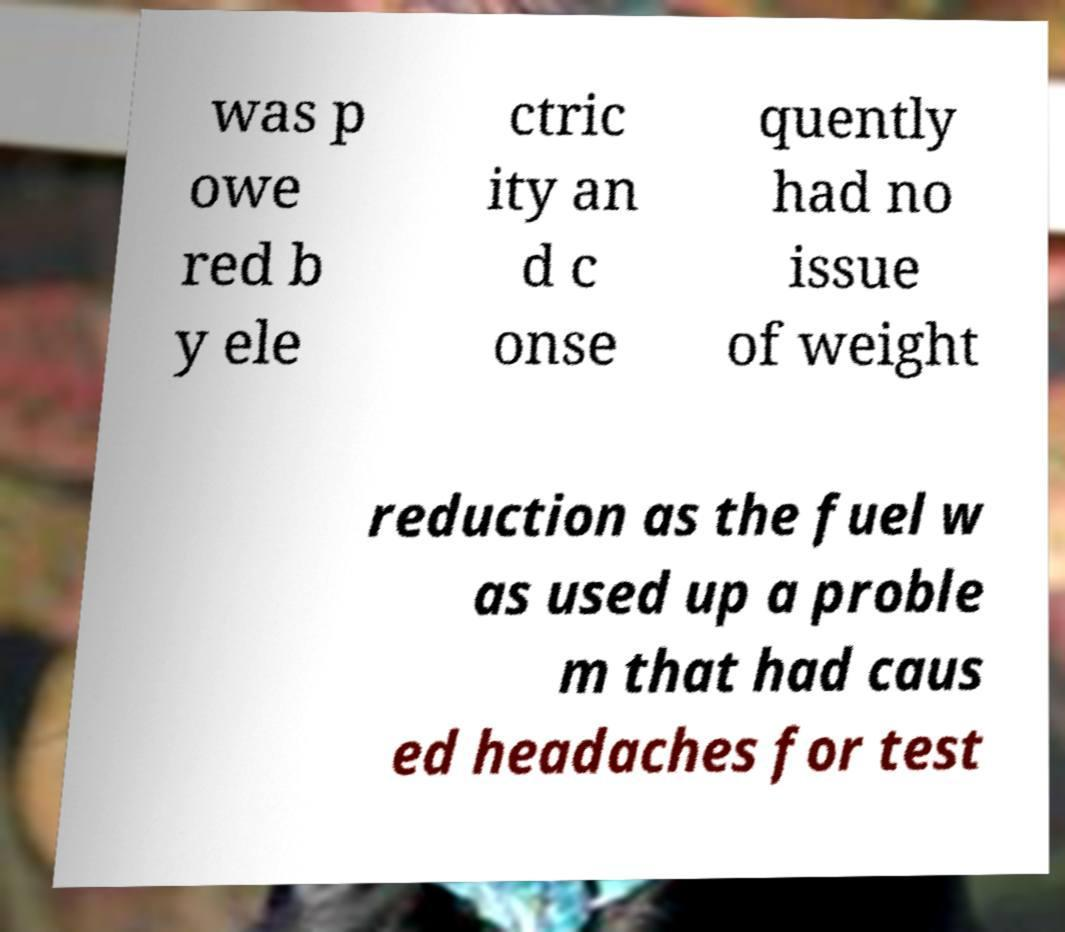Please identify and transcribe the text found in this image. was p owe red b y ele ctric ity an d c onse quently had no issue of weight reduction as the fuel w as used up a proble m that had caus ed headaches for test 